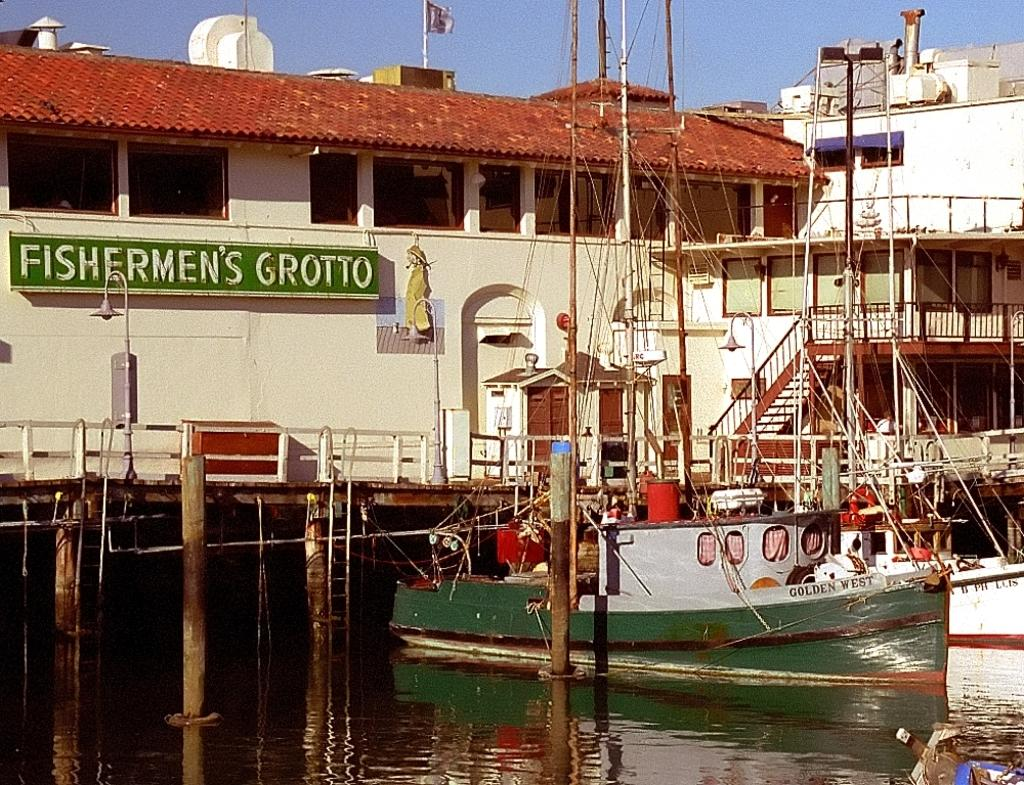Provide a one-sentence caption for the provided image. A green fishing boat sits in the water next to the Fishermans Grotto. 